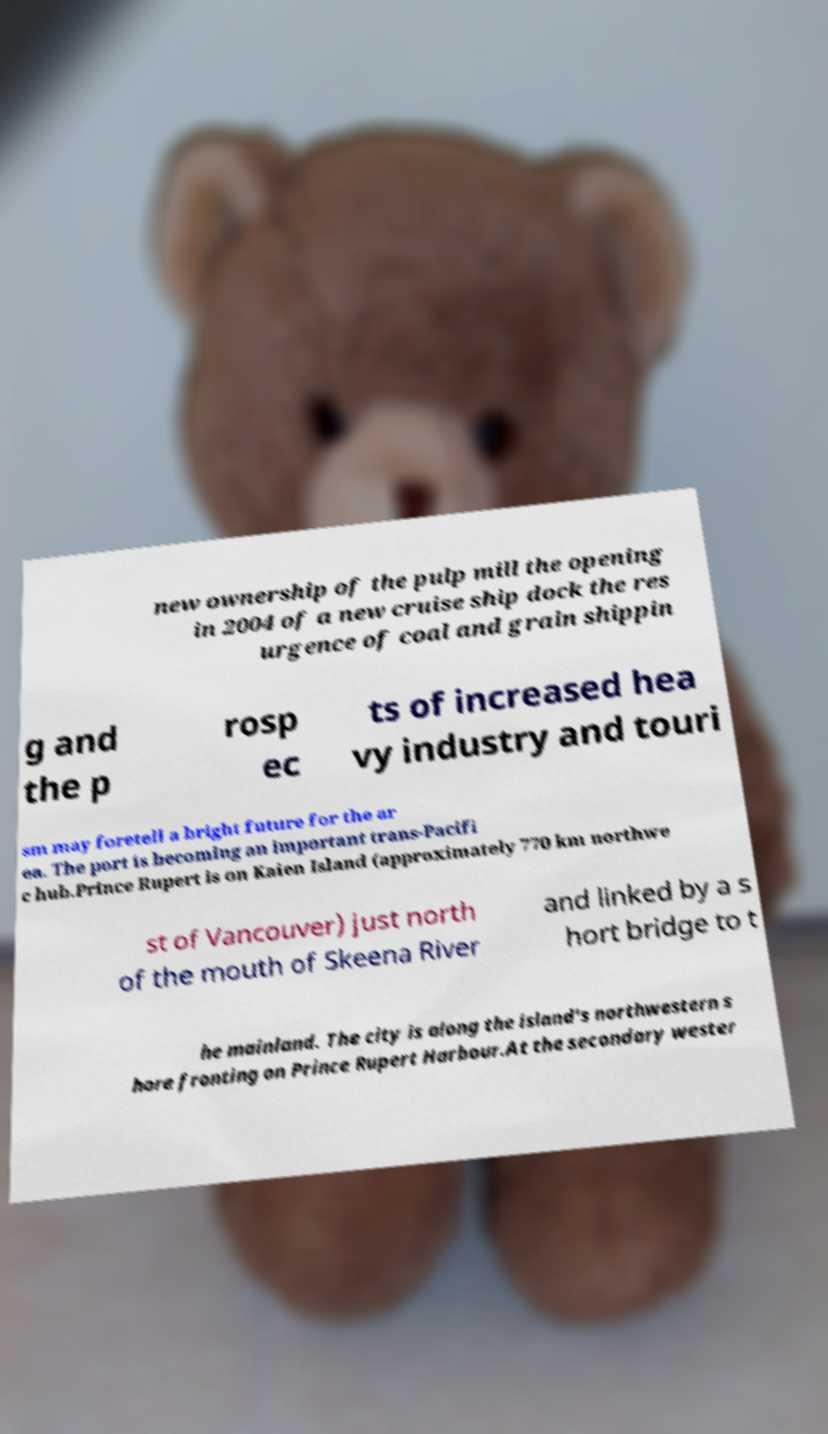Please read and relay the text visible in this image. What does it say? new ownership of the pulp mill the opening in 2004 of a new cruise ship dock the res urgence of coal and grain shippin g and the p rosp ec ts of increased hea vy industry and touri sm may foretell a bright future for the ar ea. The port is becoming an important trans-Pacifi c hub.Prince Rupert is on Kaien Island (approximately 770 km northwe st of Vancouver) just north of the mouth of Skeena River and linked by a s hort bridge to t he mainland. The city is along the island's northwestern s hore fronting on Prince Rupert Harbour.At the secondary wester 